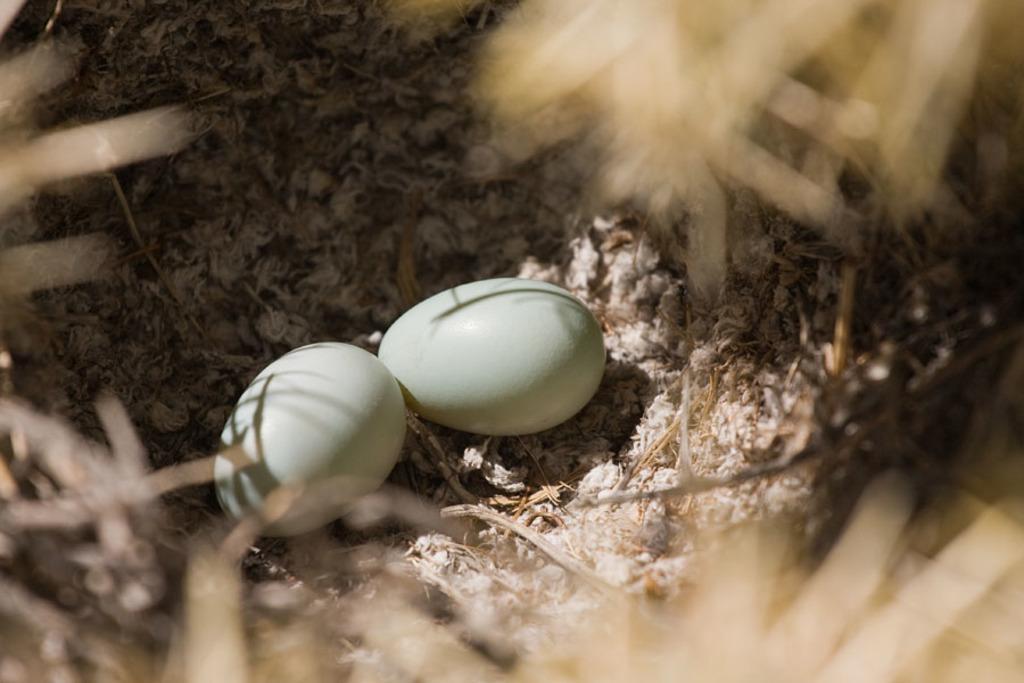Please provide a concise description of this image. Here in this picture we can see two eggs present on the ground and around it we can see everything in blurry manner. 